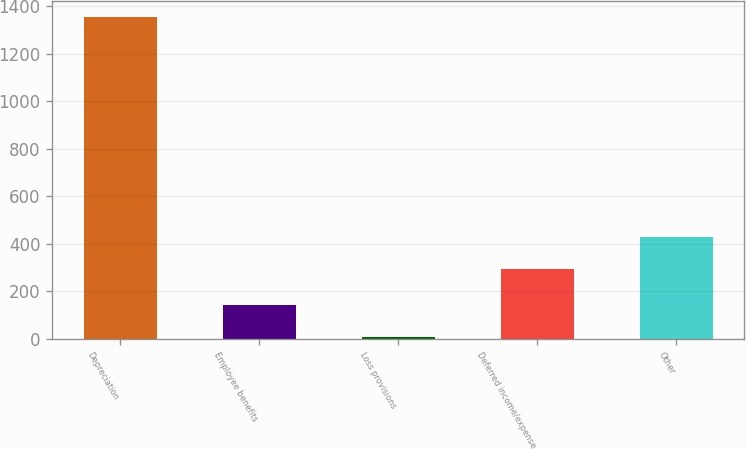Convert chart to OTSL. <chart><loc_0><loc_0><loc_500><loc_500><bar_chart><fcel>Depreciation<fcel>Employee benefits<fcel>Loss provisions<fcel>Deferred income/expense<fcel>Other<nl><fcel>1353<fcel>143.4<fcel>9<fcel>294<fcel>428.4<nl></chart> 